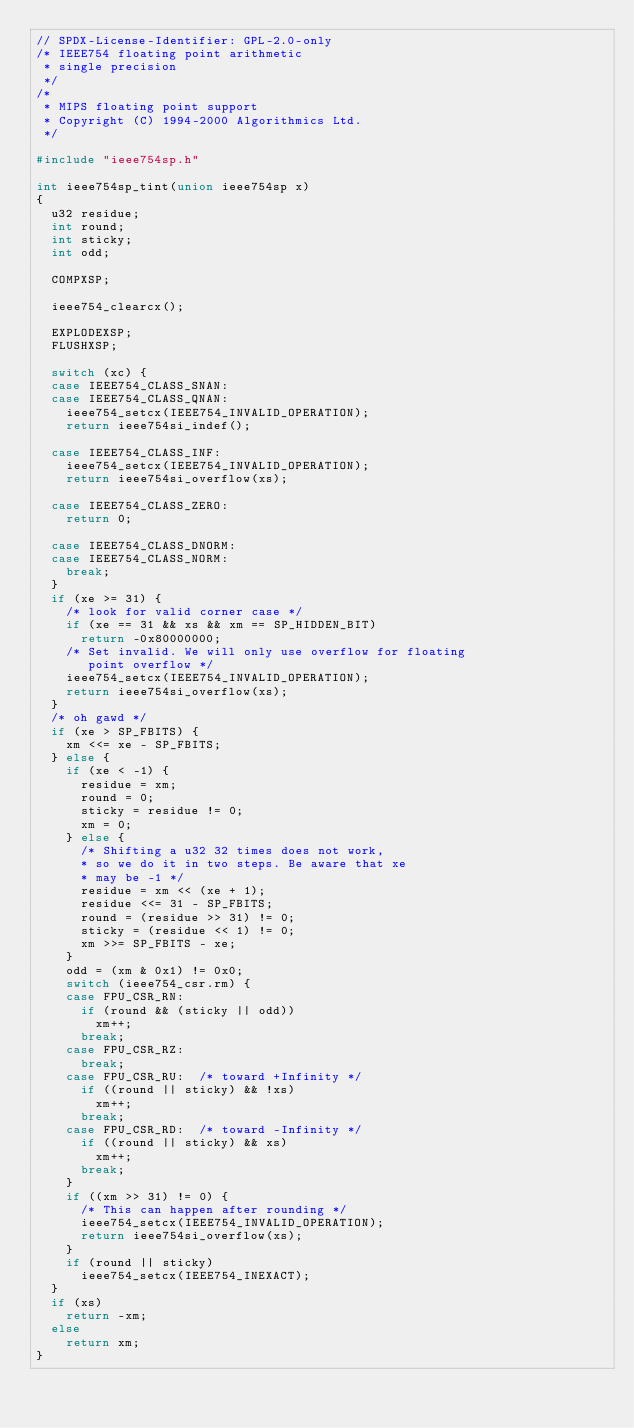<code> <loc_0><loc_0><loc_500><loc_500><_C_>// SPDX-License-Identifier: GPL-2.0-only
/* IEEE754 floating point arithmetic
 * single precision
 */
/*
 * MIPS floating point support
 * Copyright (C) 1994-2000 Algorithmics Ltd.
 */

#include "ieee754sp.h"

int ieee754sp_tint(union ieee754sp x)
{
	u32 residue;
	int round;
	int sticky;
	int odd;

	COMPXSP;

	ieee754_clearcx();

	EXPLODEXSP;
	FLUSHXSP;

	switch (xc) {
	case IEEE754_CLASS_SNAN:
	case IEEE754_CLASS_QNAN:
		ieee754_setcx(IEEE754_INVALID_OPERATION);
		return ieee754si_indef();

	case IEEE754_CLASS_INF:
		ieee754_setcx(IEEE754_INVALID_OPERATION);
		return ieee754si_overflow(xs);

	case IEEE754_CLASS_ZERO:
		return 0;

	case IEEE754_CLASS_DNORM:
	case IEEE754_CLASS_NORM:
		break;
	}
	if (xe >= 31) {
		/* look for valid corner case */
		if (xe == 31 && xs && xm == SP_HIDDEN_BIT)
			return -0x80000000;
		/* Set invalid. We will only use overflow for floating
		   point overflow */
		ieee754_setcx(IEEE754_INVALID_OPERATION);
		return ieee754si_overflow(xs);
	}
	/* oh gawd */
	if (xe > SP_FBITS) {
		xm <<= xe - SP_FBITS;
	} else {
		if (xe < -1) {
			residue = xm;
			round = 0;
			sticky = residue != 0;
			xm = 0;
		} else {
			/* Shifting a u32 32 times does not work,
			* so we do it in two steps. Be aware that xe
			* may be -1 */
			residue = xm << (xe + 1);
			residue <<= 31 - SP_FBITS;
			round = (residue >> 31) != 0;
			sticky = (residue << 1) != 0;
			xm >>= SP_FBITS - xe;
		}
		odd = (xm & 0x1) != 0x0;
		switch (ieee754_csr.rm) {
		case FPU_CSR_RN:
			if (round && (sticky || odd))
				xm++;
			break;
		case FPU_CSR_RZ:
			break;
		case FPU_CSR_RU:	/* toward +Infinity */
			if ((round || sticky) && !xs)
				xm++;
			break;
		case FPU_CSR_RD:	/* toward -Infinity */
			if ((round || sticky) && xs)
				xm++;
			break;
		}
		if ((xm >> 31) != 0) {
			/* This can happen after rounding */
			ieee754_setcx(IEEE754_INVALID_OPERATION);
			return ieee754si_overflow(xs);
		}
		if (round || sticky)
			ieee754_setcx(IEEE754_INEXACT);
	}
	if (xs)
		return -xm;
	else
		return xm;
}
</code> 